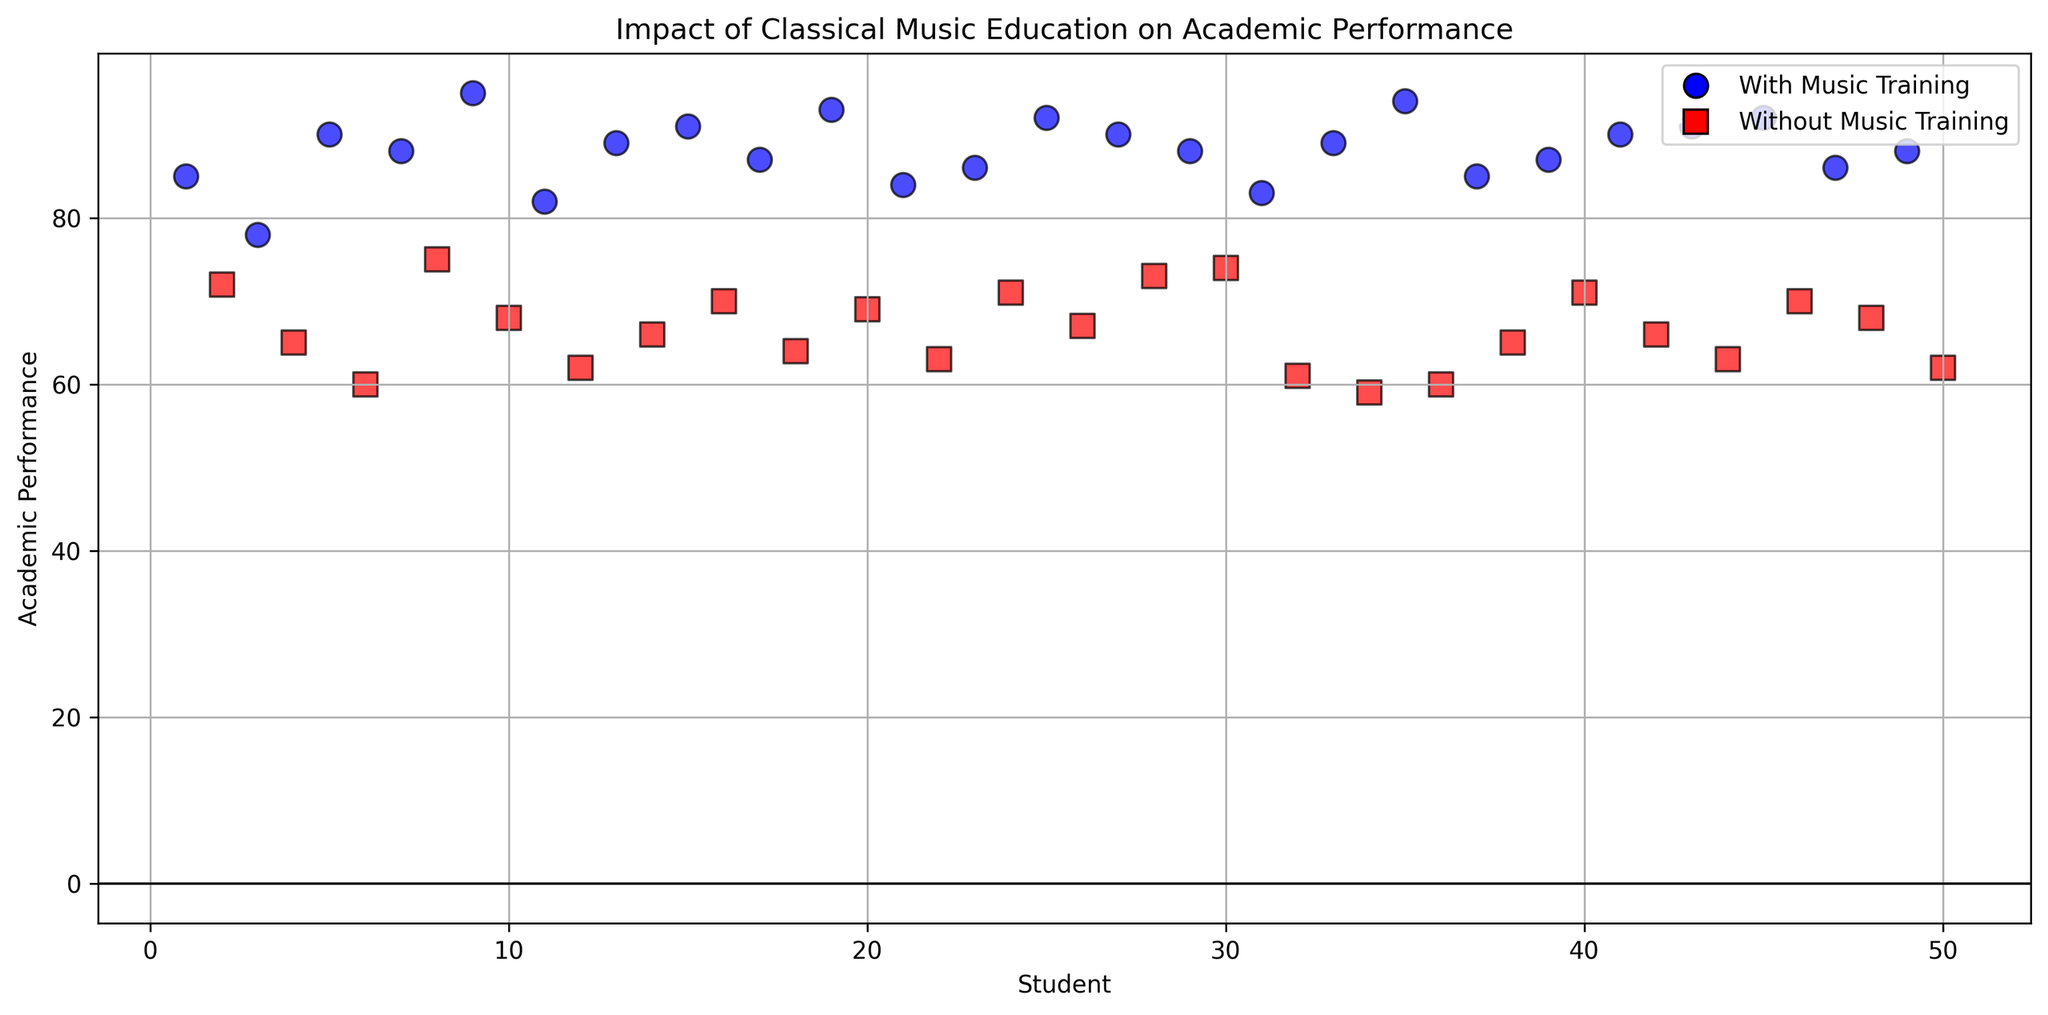What is the average academic performance of students with music training? To find the average academic performance, sum the performances of students with music training and divide by the number of such students. The performances are (85, 78, 90, 88, 95, 82, 89, 91, 87, 93, 84, 86, 92, 90, 88, 83, 89, 94, 85, 87, 90, 91, 92, 86, 88). Sum these values to get 2188 and divide by 25 (number of students with music training): 2188 / 25 = 87.52.
Answer: 87.52 How many students without music training scored above 65? Look at the scatter plot and identify the data points for students without music training (represented by red squares) who scored above 65. The scores are 72, 75, 68, 70, 71, 69, 71, 73, 74, 67, 71, and 70. Count these points: there are 12 students.
Answer: 12 Which group has the highest academic performance score and what is that score? Identify the highest point on the scatter plot on the y-axis for both groups. The highest score for students with music training (blue circles) is 95 and for those without music training (red squares) is 75. The highest of these is 95.
Answer: Students with music training, 95 What's the median academic performance of students without music training? Arrange the academic performance scores of students without music training and find the middle value. Scores are (59, 60, 60, 62, 62, 63, 63, 64, 65, 65, 66, 66, 67, 68, 68, 69, 70, 70, 71, 71, 71, 72, 73, 74, 75). The middle (median) value in the ordered list of 25 scores is the 13th score, which is 67.
Answer: 67 How does the academic performance of the top 5 students with music training compare to the top 5 students without music training? Identify the top 5 scores for each group from the scatter plot. For students with music training, the top 5 scores are 95, 94, 93, 92, 92. For students without music training, the top 5 scores are 75, 74, 73, 72, 71. Noticeably, all top 5 scores from students with music training are higher than those without music training.
Answer: Students with music training have higher performance Is there a visible difference in clustering between students with and without music training? Observe the scatter plot to see how closely the data points are clustered for the two groups. Students with music training (blue circles) tend to have scores clustered in the 80-95 range, while students without music training (red squares) are mostly below 75, indicating two distinct clusters with higher scores for students with music training.
Answer: Yes, with music training clustered higher What is the range of academic performance scores for students without music training? Find the highest and lowest academic performance scores for students without music training. The highest is 75 and the lowest is 59. Calculate the range by subtracting the lowest from the highest: 75 - 59 = 16.
Answer: 16 